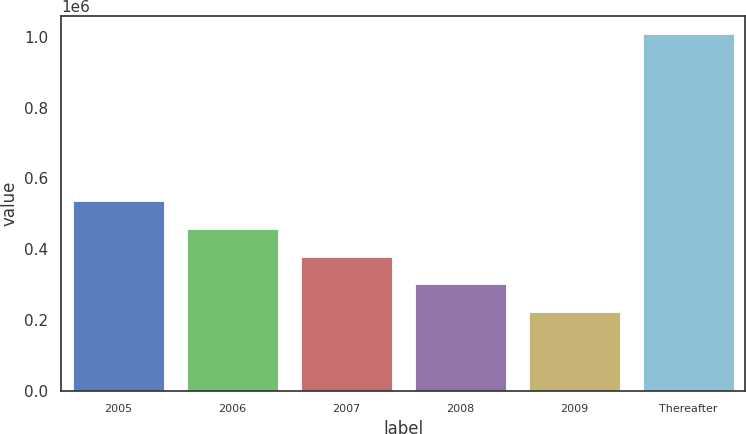Convert chart. <chart><loc_0><loc_0><loc_500><loc_500><bar_chart><fcel>2005<fcel>2006<fcel>2007<fcel>2008<fcel>2009<fcel>Thereafter<nl><fcel>536171<fcel>457733<fcel>379295<fcel>300857<fcel>222419<fcel>1.0068e+06<nl></chart> 